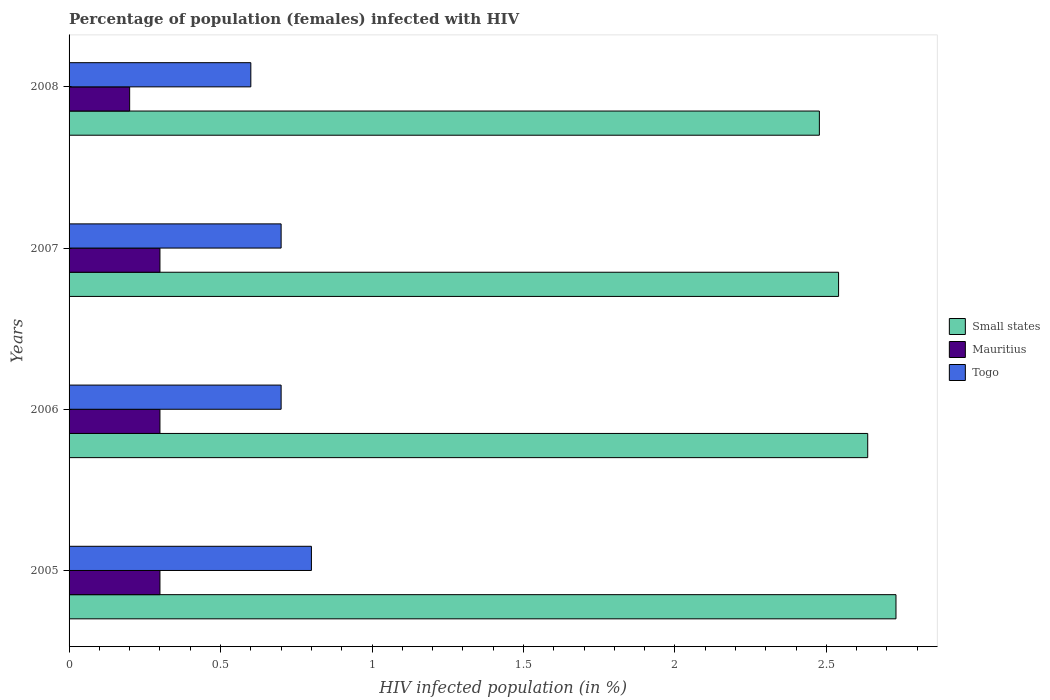How many groups of bars are there?
Your answer should be very brief. 4. How many bars are there on the 2nd tick from the top?
Your answer should be compact. 3. How many bars are there on the 4th tick from the bottom?
Keep it short and to the point. 3. What is the percentage of HIV infected female population in Mauritius in 2005?
Keep it short and to the point. 0.3. Across all years, what is the minimum percentage of HIV infected female population in Mauritius?
Provide a short and direct response. 0.2. In which year was the percentage of HIV infected female population in Small states minimum?
Your answer should be very brief. 2008. What is the total percentage of HIV infected female population in Togo in the graph?
Your answer should be compact. 2.8. What is the difference between the percentage of HIV infected female population in Mauritius in 2006 and the percentage of HIV infected female population in Togo in 2005?
Keep it short and to the point. -0.5. What is the average percentage of HIV infected female population in Mauritius per year?
Your answer should be very brief. 0.27. In the year 2007, what is the difference between the percentage of HIV infected female population in Mauritius and percentage of HIV infected female population in Togo?
Give a very brief answer. -0.4. What is the difference between the highest and the second highest percentage of HIV infected female population in Small states?
Your response must be concise. 0.09. What is the difference between the highest and the lowest percentage of HIV infected female population in Mauritius?
Offer a terse response. 0.1. What does the 3rd bar from the top in 2007 represents?
Your answer should be compact. Small states. What does the 3rd bar from the bottom in 2005 represents?
Your answer should be very brief. Togo. Is it the case that in every year, the sum of the percentage of HIV infected female population in Togo and percentage of HIV infected female population in Small states is greater than the percentage of HIV infected female population in Mauritius?
Keep it short and to the point. Yes. What is the difference between two consecutive major ticks on the X-axis?
Give a very brief answer. 0.5. Are the values on the major ticks of X-axis written in scientific E-notation?
Your answer should be very brief. No. Does the graph contain grids?
Offer a terse response. No. What is the title of the graph?
Offer a terse response. Percentage of population (females) infected with HIV. Does "Bosnia and Herzegovina" appear as one of the legend labels in the graph?
Your answer should be compact. No. What is the label or title of the X-axis?
Keep it short and to the point. HIV infected population (in %). What is the HIV infected population (in %) of Small states in 2005?
Offer a terse response. 2.73. What is the HIV infected population (in %) of Togo in 2005?
Make the answer very short. 0.8. What is the HIV infected population (in %) of Small states in 2006?
Ensure brevity in your answer.  2.64. What is the HIV infected population (in %) in Mauritius in 2006?
Offer a very short reply. 0.3. What is the HIV infected population (in %) of Small states in 2007?
Keep it short and to the point. 2.54. What is the HIV infected population (in %) in Togo in 2007?
Offer a terse response. 0.7. What is the HIV infected population (in %) in Small states in 2008?
Keep it short and to the point. 2.48. Across all years, what is the maximum HIV infected population (in %) in Small states?
Your answer should be very brief. 2.73. Across all years, what is the maximum HIV infected population (in %) of Mauritius?
Keep it short and to the point. 0.3. Across all years, what is the maximum HIV infected population (in %) in Togo?
Your response must be concise. 0.8. Across all years, what is the minimum HIV infected population (in %) in Small states?
Provide a succinct answer. 2.48. Across all years, what is the minimum HIV infected population (in %) of Mauritius?
Your answer should be very brief. 0.2. What is the total HIV infected population (in %) of Small states in the graph?
Provide a succinct answer. 10.38. What is the total HIV infected population (in %) of Mauritius in the graph?
Provide a succinct answer. 1.1. What is the total HIV infected population (in %) in Togo in the graph?
Your answer should be compact. 2.8. What is the difference between the HIV infected population (in %) of Small states in 2005 and that in 2006?
Provide a succinct answer. 0.09. What is the difference between the HIV infected population (in %) of Small states in 2005 and that in 2007?
Your answer should be compact. 0.19. What is the difference between the HIV infected population (in %) of Togo in 2005 and that in 2007?
Your response must be concise. 0.1. What is the difference between the HIV infected population (in %) in Small states in 2005 and that in 2008?
Provide a short and direct response. 0.25. What is the difference between the HIV infected population (in %) in Small states in 2006 and that in 2007?
Ensure brevity in your answer.  0.1. What is the difference between the HIV infected population (in %) in Small states in 2006 and that in 2008?
Your response must be concise. 0.16. What is the difference between the HIV infected population (in %) of Mauritius in 2006 and that in 2008?
Your response must be concise. 0.1. What is the difference between the HIV infected population (in %) of Small states in 2007 and that in 2008?
Give a very brief answer. 0.06. What is the difference between the HIV infected population (in %) of Togo in 2007 and that in 2008?
Your answer should be very brief. 0.1. What is the difference between the HIV infected population (in %) in Small states in 2005 and the HIV infected population (in %) in Mauritius in 2006?
Provide a short and direct response. 2.43. What is the difference between the HIV infected population (in %) of Small states in 2005 and the HIV infected population (in %) of Togo in 2006?
Offer a terse response. 2.03. What is the difference between the HIV infected population (in %) in Small states in 2005 and the HIV infected population (in %) in Mauritius in 2007?
Your response must be concise. 2.43. What is the difference between the HIV infected population (in %) in Small states in 2005 and the HIV infected population (in %) in Togo in 2007?
Offer a very short reply. 2.03. What is the difference between the HIV infected population (in %) in Small states in 2005 and the HIV infected population (in %) in Mauritius in 2008?
Your answer should be compact. 2.53. What is the difference between the HIV infected population (in %) in Small states in 2005 and the HIV infected population (in %) in Togo in 2008?
Your answer should be compact. 2.13. What is the difference between the HIV infected population (in %) of Small states in 2006 and the HIV infected population (in %) of Mauritius in 2007?
Keep it short and to the point. 2.34. What is the difference between the HIV infected population (in %) of Small states in 2006 and the HIV infected population (in %) of Togo in 2007?
Keep it short and to the point. 1.94. What is the difference between the HIV infected population (in %) in Mauritius in 2006 and the HIV infected population (in %) in Togo in 2007?
Give a very brief answer. -0.4. What is the difference between the HIV infected population (in %) of Small states in 2006 and the HIV infected population (in %) of Mauritius in 2008?
Provide a short and direct response. 2.44. What is the difference between the HIV infected population (in %) in Small states in 2006 and the HIV infected population (in %) in Togo in 2008?
Keep it short and to the point. 2.04. What is the difference between the HIV infected population (in %) of Small states in 2007 and the HIV infected population (in %) of Mauritius in 2008?
Your answer should be compact. 2.34. What is the difference between the HIV infected population (in %) of Small states in 2007 and the HIV infected population (in %) of Togo in 2008?
Your answer should be very brief. 1.94. What is the difference between the HIV infected population (in %) in Mauritius in 2007 and the HIV infected population (in %) in Togo in 2008?
Offer a terse response. -0.3. What is the average HIV infected population (in %) of Small states per year?
Make the answer very short. 2.6. What is the average HIV infected population (in %) in Mauritius per year?
Make the answer very short. 0.28. In the year 2005, what is the difference between the HIV infected population (in %) in Small states and HIV infected population (in %) in Mauritius?
Your answer should be compact. 2.43. In the year 2005, what is the difference between the HIV infected population (in %) of Small states and HIV infected population (in %) of Togo?
Offer a very short reply. 1.93. In the year 2006, what is the difference between the HIV infected population (in %) in Small states and HIV infected population (in %) in Mauritius?
Your answer should be very brief. 2.34. In the year 2006, what is the difference between the HIV infected population (in %) of Small states and HIV infected population (in %) of Togo?
Give a very brief answer. 1.94. In the year 2007, what is the difference between the HIV infected population (in %) in Small states and HIV infected population (in %) in Mauritius?
Your answer should be very brief. 2.24. In the year 2007, what is the difference between the HIV infected population (in %) of Small states and HIV infected population (in %) of Togo?
Offer a very short reply. 1.84. In the year 2007, what is the difference between the HIV infected population (in %) of Mauritius and HIV infected population (in %) of Togo?
Ensure brevity in your answer.  -0.4. In the year 2008, what is the difference between the HIV infected population (in %) in Small states and HIV infected population (in %) in Mauritius?
Offer a very short reply. 2.28. In the year 2008, what is the difference between the HIV infected population (in %) of Small states and HIV infected population (in %) of Togo?
Offer a terse response. 1.88. In the year 2008, what is the difference between the HIV infected population (in %) in Mauritius and HIV infected population (in %) in Togo?
Offer a terse response. -0.4. What is the ratio of the HIV infected population (in %) of Small states in 2005 to that in 2006?
Provide a succinct answer. 1.04. What is the ratio of the HIV infected population (in %) of Mauritius in 2005 to that in 2006?
Your answer should be compact. 1. What is the ratio of the HIV infected population (in %) in Small states in 2005 to that in 2007?
Provide a succinct answer. 1.07. What is the ratio of the HIV infected population (in %) of Togo in 2005 to that in 2007?
Ensure brevity in your answer.  1.14. What is the ratio of the HIV infected population (in %) in Small states in 2005 to that in 2008?
Offer a very short reply. 1.1. What is the ratio of the HIV infected population (in %) of Togo in 2005 to that in 2008?
Your answer should be compact. 1.33. What is the ratio of the HIV infected population (in %) in Small states in 2006 to that in 2007?
Offer a very short reply. 1.04. What is the ratio of the HIV infected population (in %) in Small states in 2006 to that in 2008?
Offer a very short reply. 1.06. What is the ratio of the HIV infected population (in %) in Mauritius in 2006 to that in 2008?
Provide a succinct answer. 1.5. What is the ratio of the HIV infected population (in %) in Small states in 2007 to that in 2008?
Provide a short and direct response. 1.03. What is the ratio of the HIV infected population (in %) of Mauritius in 2007 to that in 2008?
Your answer should be compact. 1.5. What is the difference between the highest and the second highest HIV infected population (in %) in Small states?
Keep it short and to the point. 0.09. What is the difference between the highest and the second highest HIV infected population (in %) in Mauritius?
Offer a very short reply. 0. What is the difference between the highest and the lowest HIV infected population (in %) of Small states?
Give a very brief answer. 0.25. What is the difference between the highest and the lowest HIV infected population (in %) of Mauritius?
Make the answer very short. 0.1. What is the difference between the highest and the lowest HIV infected population (in %) of Togo?
Offer a terse response. 0.2. 